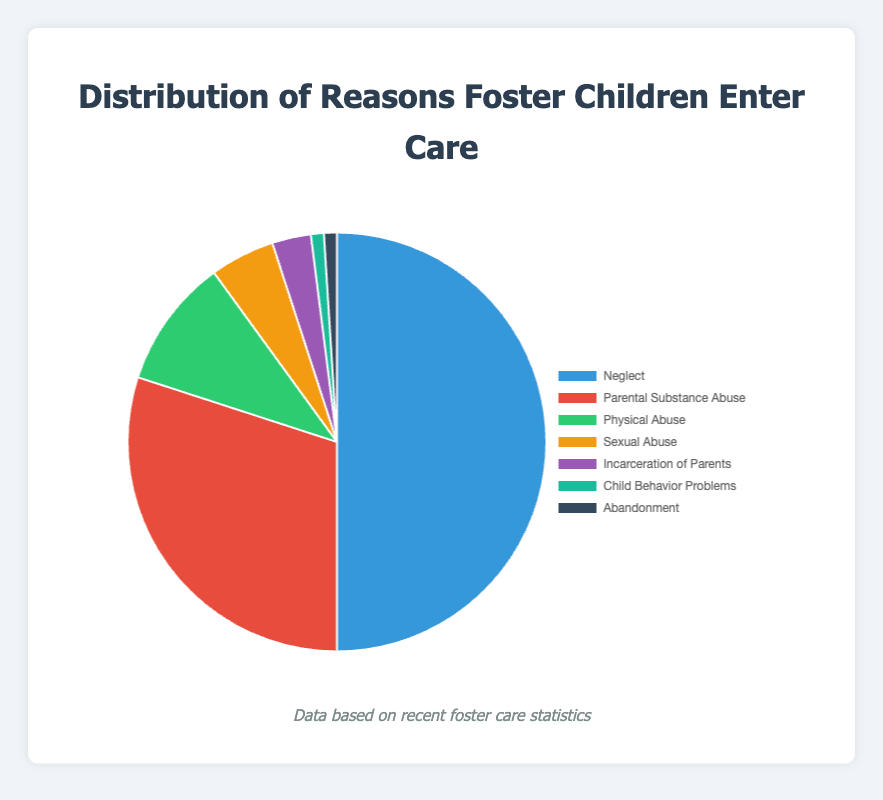What percentage of foster children enter care due to neglect? The pie chart shows the percentage distribution of reasons children enter foster care. The section representing neglect is labeled with its percentage.
Answer: 50% How much higher is the percentage of children entering foster care due to parental substance abuse compared to those entering due to physical abuse? From the chart, parental substance abuse accounts for 30%, and physical abuse accounts for 10%. Subtracting these values gives 30% - 10% = 20%.
Answer: 20% What is the total percentage of children entering foster care due to reasons other than neglect and parental substance abuse? The total percentage is the sum of physical abuse (10%), sexual abuse (5%), incarceration of parents (3%), child behavior problems (1%), and abandonment (1%). Summing these values gives 10% + 5% + 3% + 1% + 1% = 20%.
Answer: 20% Which reason accounts for the smallest percentage of children entering foster care? The chart shows the smallest slices which are labeled with child behavior problems (1%) and abandonment (1%).
Answer: Child behavior problems and abandonment What is the combined percentage of children entering foster care due to sexual abuse and incarceration of parents? Adding the percentages for sexual abuse (5%) and incarceration of parents (3%) results in 5% + 3% = 8%.
Answer: 8% Which reason is depicted using the color blue? The chart indicates neglect with a blue section.
Answer: Neglect How many reasons that children enter foster care have a percentage of 5% or more? Identify and count the slices with 5% or larger: neglect (50%), parental substance abuse (30%), physical abuse (10%), and sexual abuse (5%). There are 4 sections.
Answer: 4 What is the difference in percentage between neglect and the other reasons combined? Neglect accounts for 50%. The combined percentage of other reasons is 50% (calculated previously). The difference is 50% - 50% = 0%.
Answer: 0% Which reason contributes the second-highest percentage of children entering foster care? The second-largest section after neglect (50%) is parental substance abuse (30%).
Answer: Parental substance abuse 